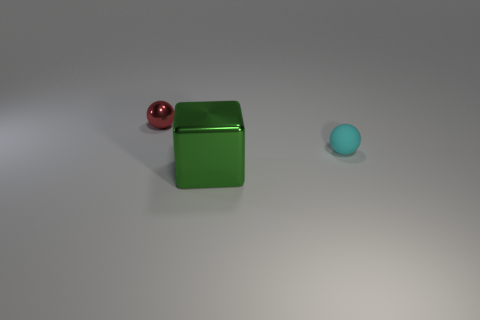Is there any other thing that has the same material as the cyan thing?
Give a very brief answer. No. Are there any cyan matte spheres on the left side of the big block?
Provide a succinct answer. No. Are there any small blue objects of the same shape as the big object?
Keep it short and to the point. No. There is a shiny object that is behind the tiny rubber sphere; does it have the same shape as the metallic thing on the right side of the red ball?
Give a very brief answer. No. Is there another sphere that has the same size as the cyan ball?
Make the answer very short. Yes. Are there the same number of tiny spheres on the left side of the matte thing and cyan things that are behind the red metal sphere?
Ensure brevity in your answer.  No. Are the small sphere that is left of the metal cube and the thing in front of the cyan rubber thing made of the same material?
Your answer should be very brief. Yes. What material is the cyan ball?
Offer a terse response. Rubber. What number of tiny matte things are there?
Give a very brief answer. 1. There is a tiny thing to the right of the metal object that is in front of the small red shiny sphere; what is it made of?
Give a very brief answer. Rubber. 